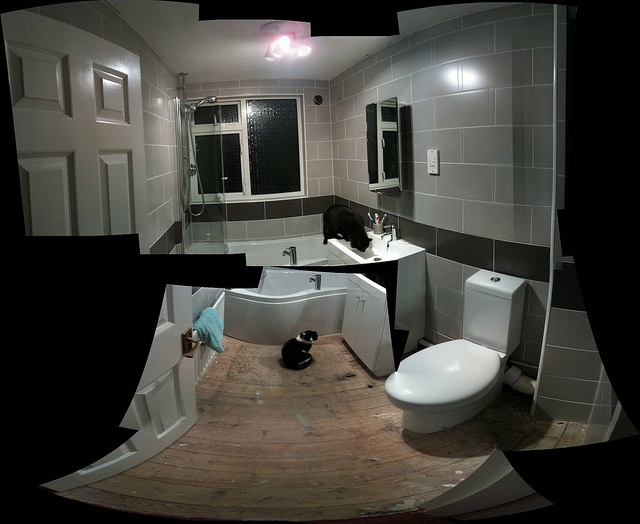Describe the objects in this image and their specific colors. I can see toilet in black, lightgray, darkgray, and gray tones, cat in black, gray, and darkgray tones, sink in black, white, darkgray, and gray tones, cat in black and gray tones, and toothbrush in black, gray, darkgray, and lightgray tones in this image. 